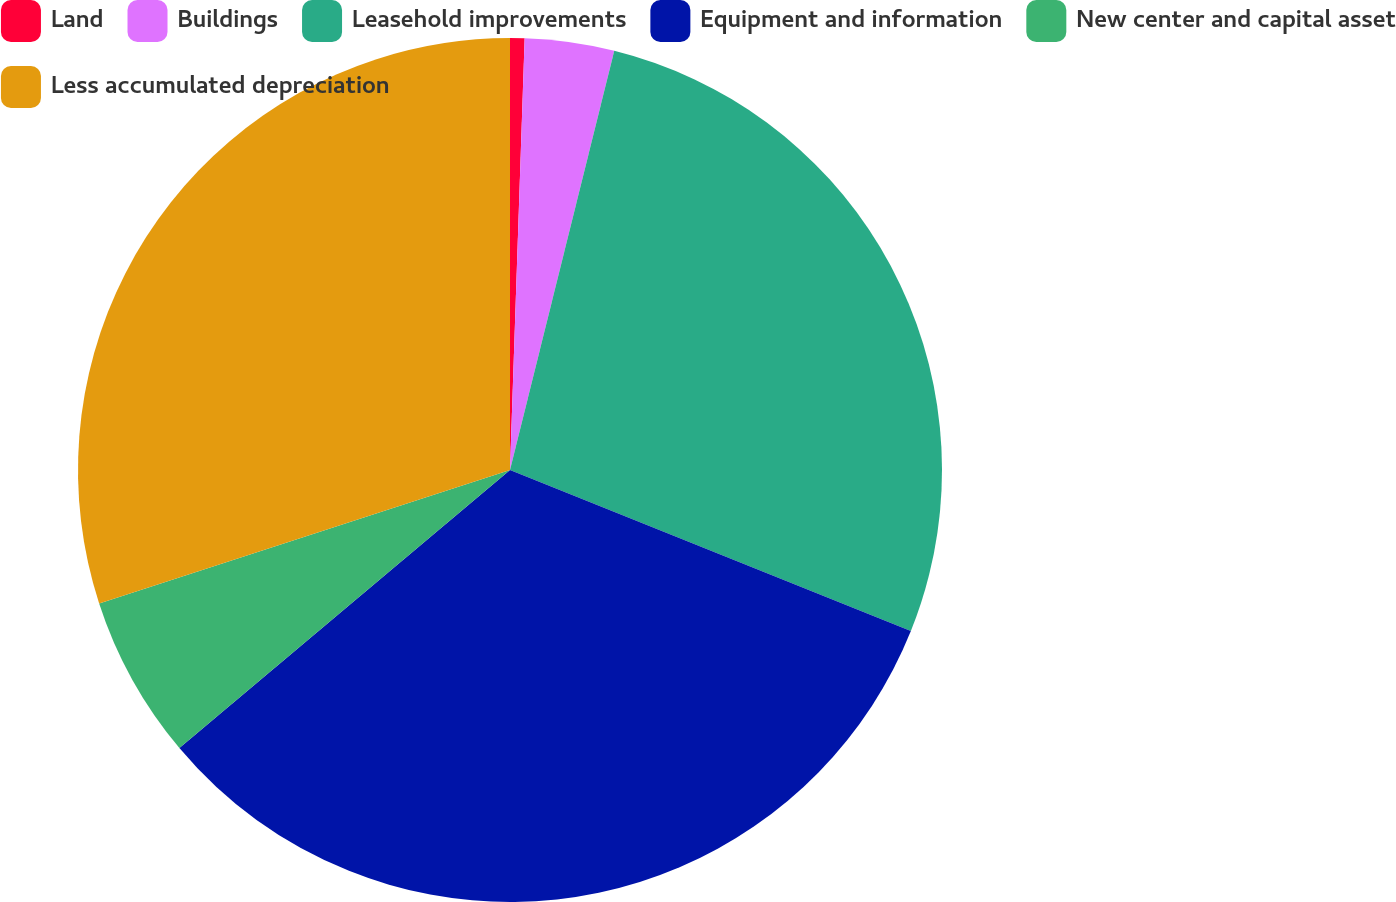Convert chart to OTSL. <chart><loc_0><loc_0><loc_500><loc_500><pie_chart><fcel>Land<fcel>Buildings<fcel>Leasehold improvements<fcel>Equipment and information<fcel>New center and capital asset<fcel>Less accumulated depreciation<nl><fcel>0.54%<fcel>3.34%<fcel>27.2%<fcel>32.79%<fcel>6.13%<fcel>30.0%<nl></chart> 